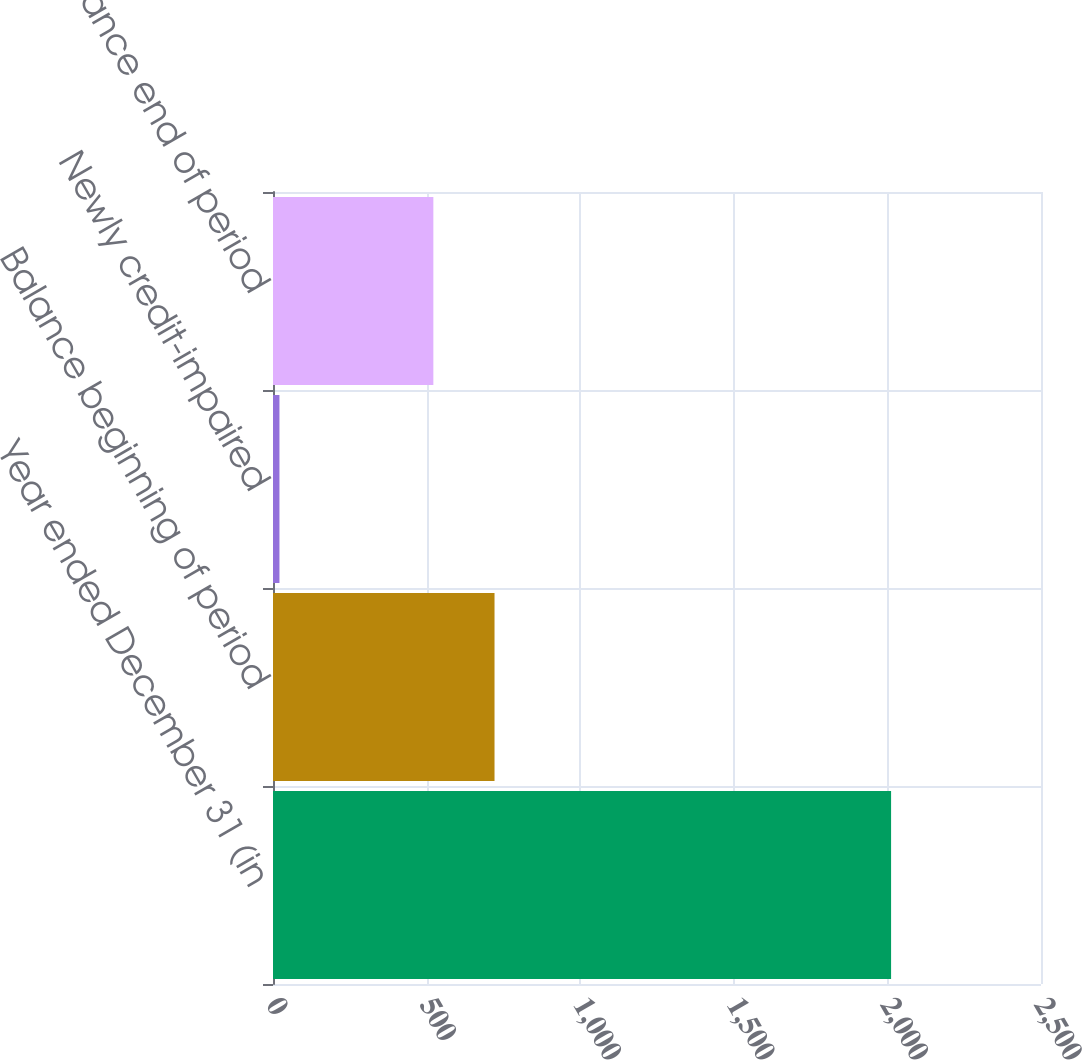Convert chart to OTSL. <chart><loc_0><loc_0><loc_500><loc_500><bar_chart><fcel>Year ended December 31 (in<fcel>Balance beginning of period<fcel>Newly credit-impaired<fcel>Balance end of period<nl><fcel>2012<fcel>721.1<fcel>21<fcel>522<nl></chart> 